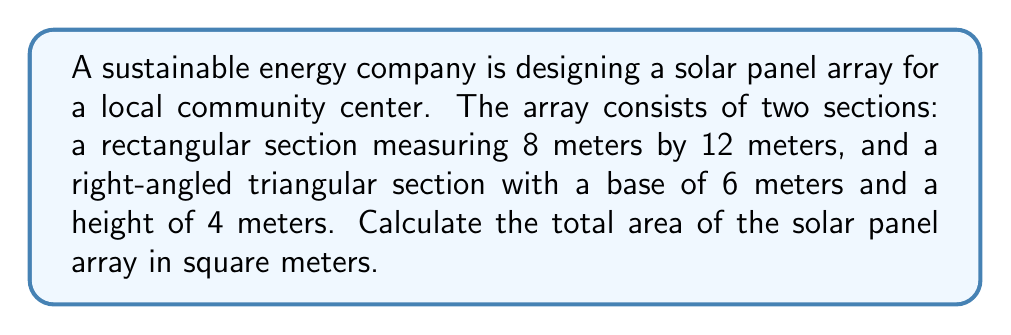Can you answer this question? To solve this problem, we need to calculate the areas of both sections and then add them together.

1. Rectangular section:
   The area of a rectangle is given by the formula: $A = l \times w$
   Where $l$ is the length and $w$ is the width.
   
   $$A_{rectangle} = 8 \text{ m} \times 12 \text{ m} = 96 \text{ m}^2$$

2. Triangular section:
   The area of a right-angled triangle is given by the formula: $A = \frac{1}{2} \times b \times h$
   Where $b$ is the base and $h$ is the height.
   
   $$A_{triangle} = \frac{1}{2} \times 6 \text{ m} \times 4 \text{ m} = 12 \text{ m}^2$$

3. Total area:
   To find the total area, we add the areas of both sections:
   
   $$A_{total} = A_{rectangle} + A_{triangle} = 96 \text{ m}^2 + 12 \text{ m}^2 = 108 \text{ m}^2$$

[asy]
unitsize(10mm);
fill((0,0)--(12,0)--(12,8)--(0,8)--cycle, gray(0.8));
fill((12,0)--(18,0)--(12,4)--cycle, gray(0.8));
draw((0,0)--(18,0)--(12,4)--(12,8)--(0,8)--cycle);
label("12 m", (6,0), S);
label("8 m", (0,4), W);
label("6 m", (15,0), S);
label("4 m", (12,2), E);
[/asy]
Answer: $108 \text{ m}^2$ 